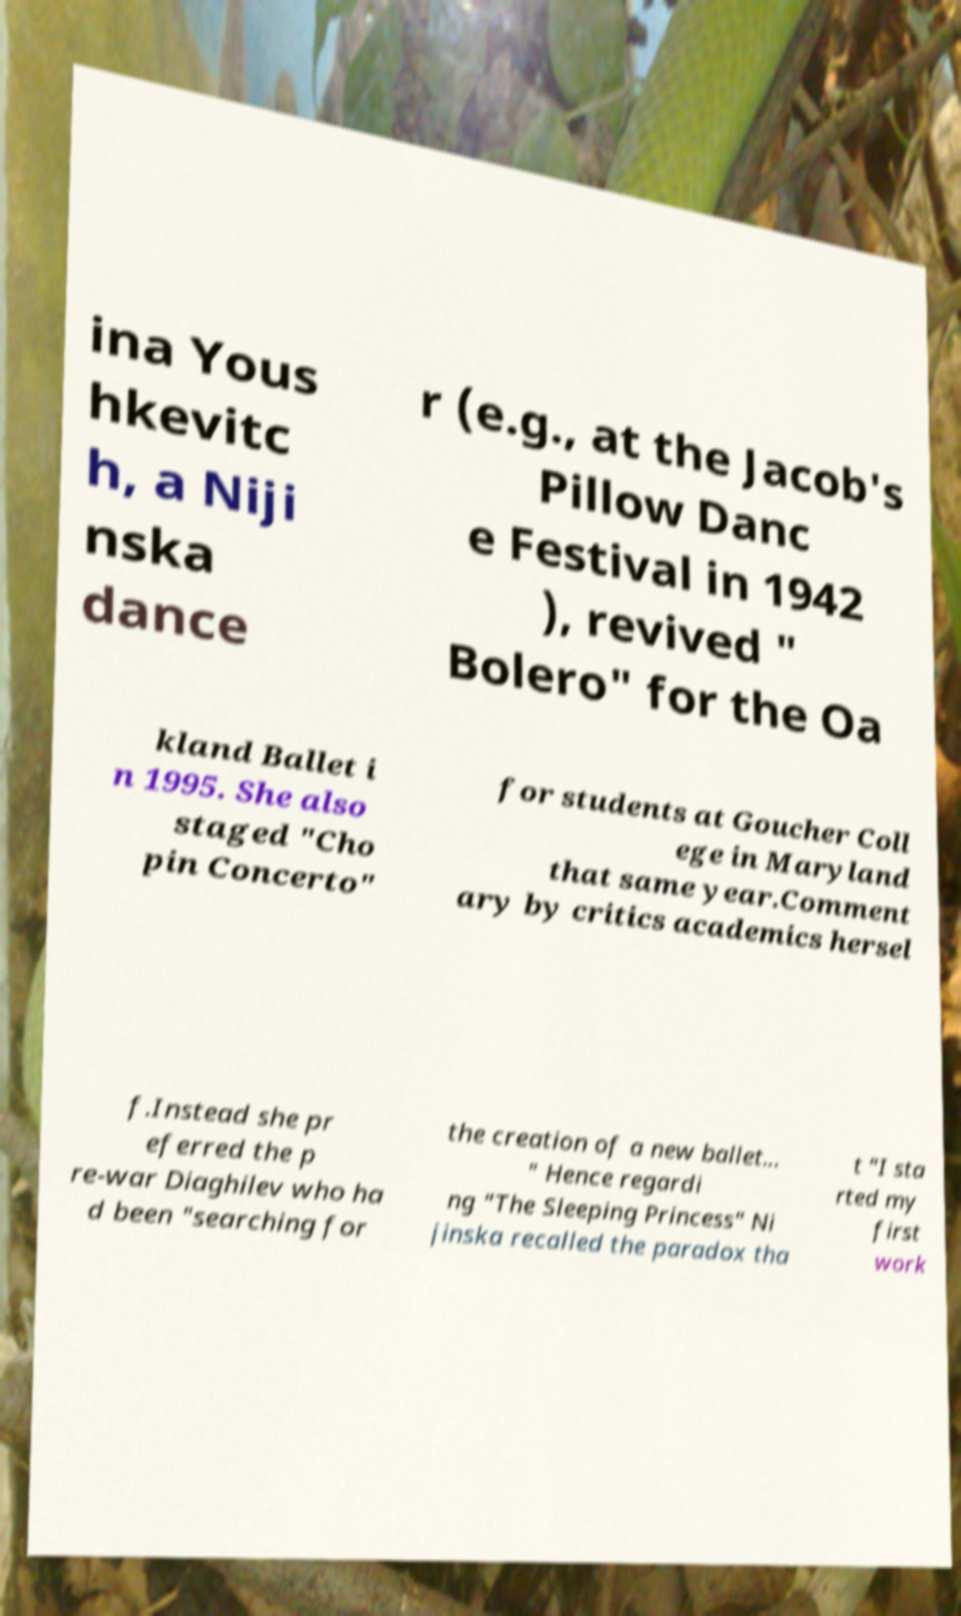Can you read and provide the text displayed in the image?This photo seems to have some interesting text. Can you extract and type it out for me? ina Yous hkevitc h, a Niji nska dance r (e.g., at the Jacob's Pillow Danc e Festival in 1942 ), revived " Bolero" for the Oa kland Ballet i n 1995. She also staged "Cho pin Concerto" for students at Goucher Coll ege in Maryland that same year.Comment ary by critics academics hersel f.Instead she pr eferred the p re-war Diaghilev who ha d been "searching for the creation of a new ballet... " Hence regardi ng "The Sleeping Princess" Ni jinska recalled the paradox tha t "I sta rted my first work 